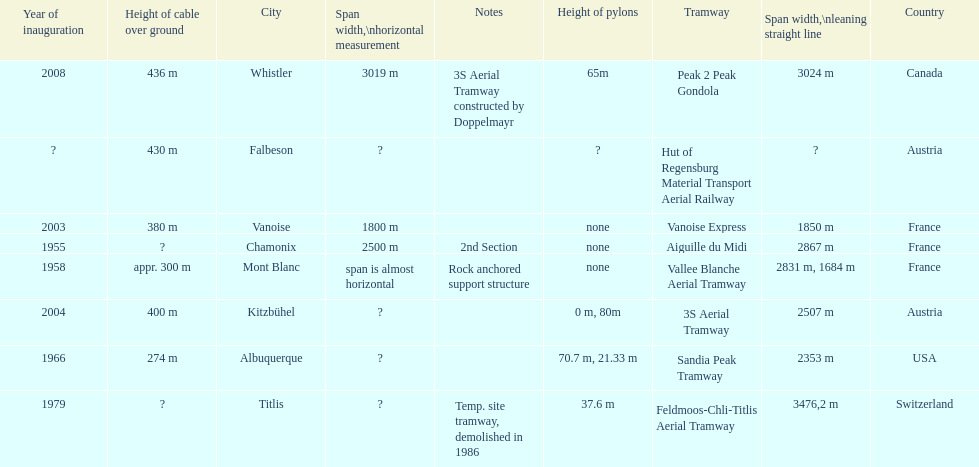How many aerial tramways are located in france? 3. 